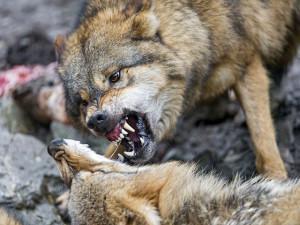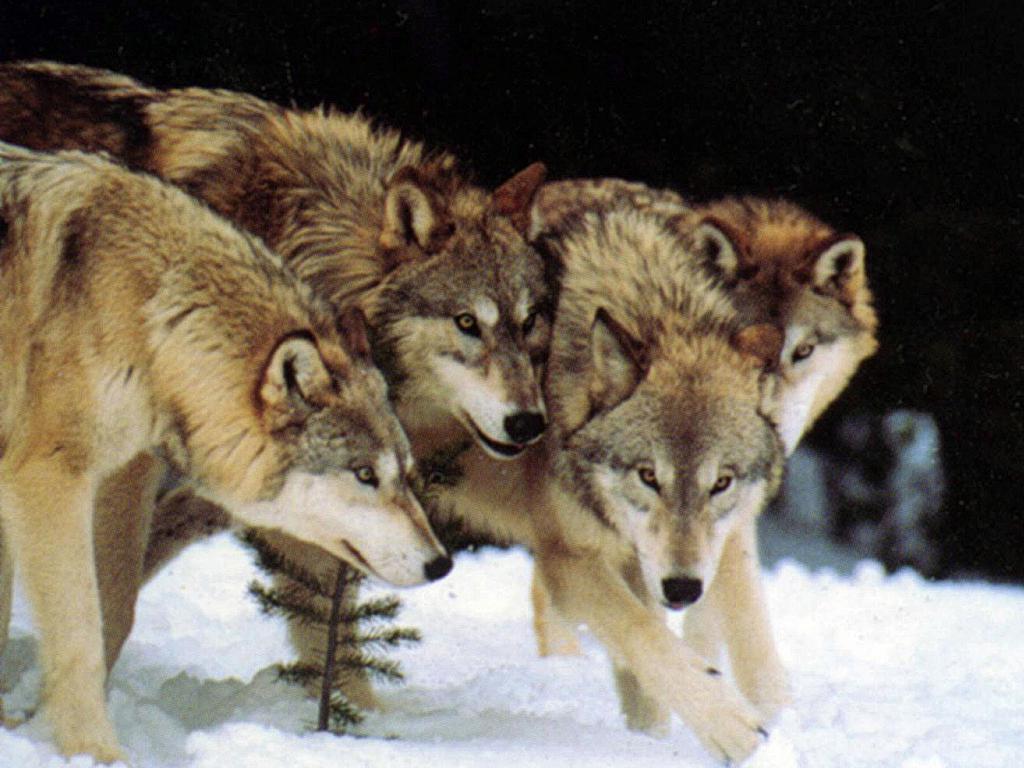The first image is the image on the left, the second image is the image on the right. Assess this claim about the two images: "An image contains exactly four wolves posed similarly and side-by-side.". Correct or not? Answer yes or no. Yes. The first image is the image on the left, the second image is the image on the right. Considering the images on both sides, is "The right image contains exactly one wolf." valid? Answer yes or no. No. 